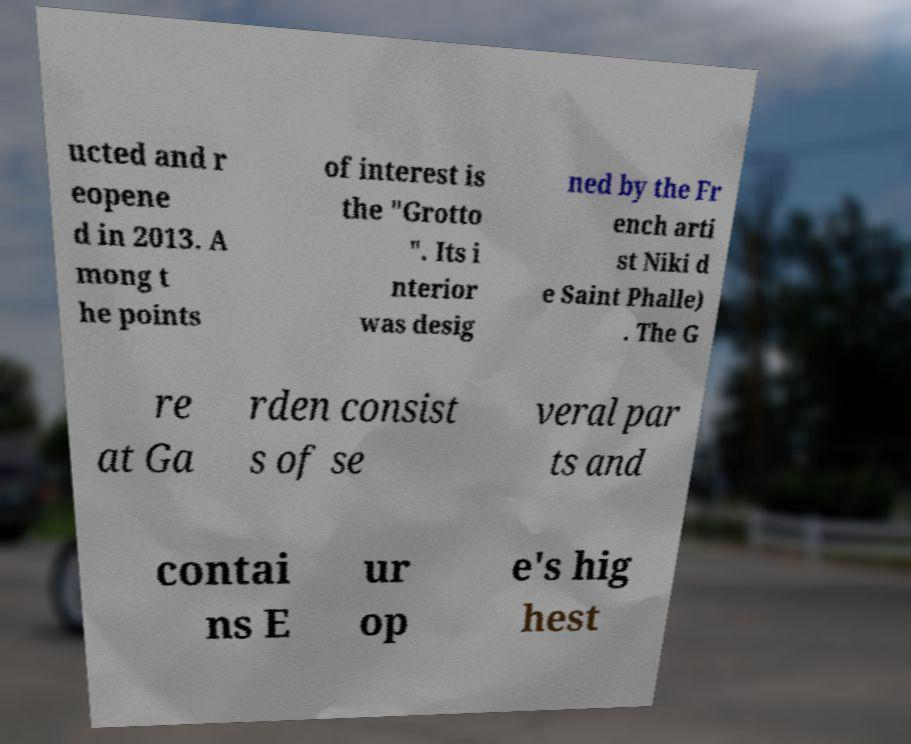Please read and relay the text visible in this image. What does it say? ucted and r eopene d in 2013. A mong t he points of interest is the "Grotto ". Its i nterior was desig ned by the Fr ench arti st Niki d e Saint Phalle) . The G re at Ga rden consist s of se veral par ts and contai ns E ur op e's hig hest 